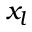<formula> <loc_0><loc_0><loc_500><loc_500>x _ { l }</formula> 